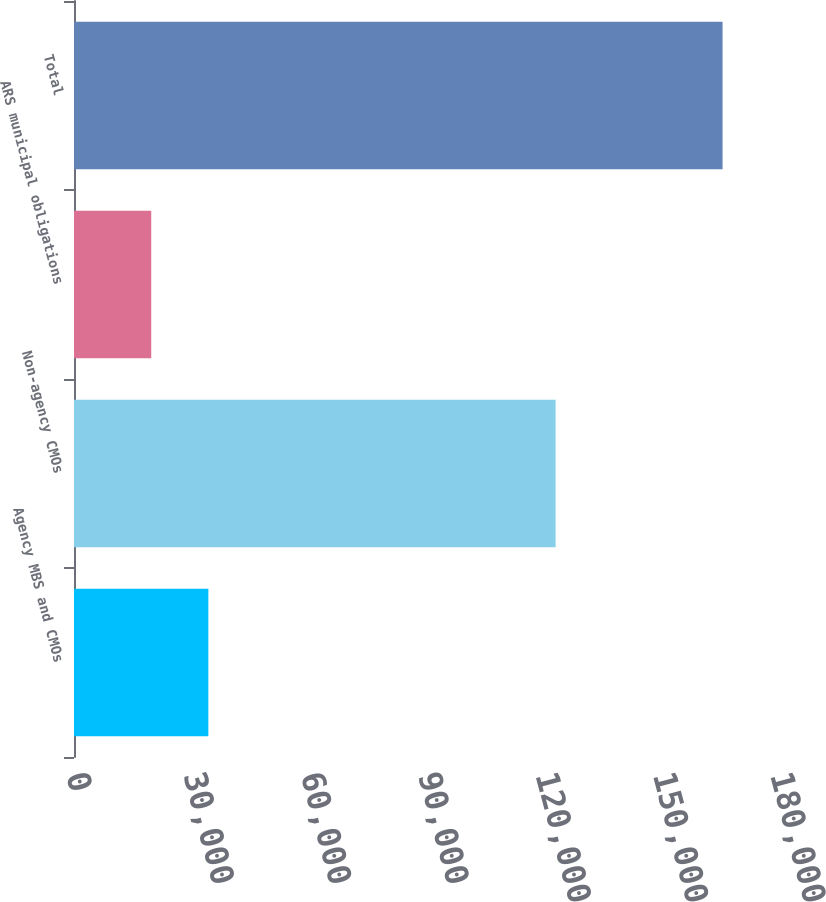Convert chart. <chart><loc_0><loc_0><loc_500><loc_500><bar_chart><fcel>Agency MBS and CMOs<fcel>Non-agency CMOs<fcel>ARS municipal obligations<fcel>Total<nl><fcel>34354.9<fcel>123139<fcel>19747<fcel>165826<nl></chart> 